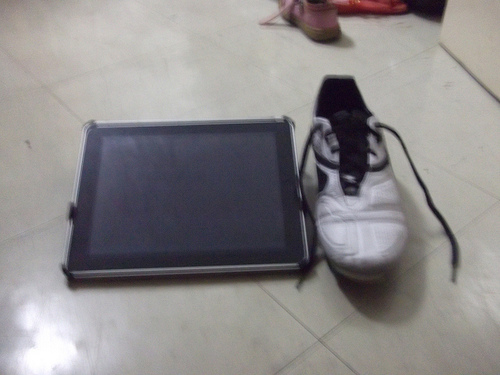<image>
Is the ipad next to the shoe? Yes. The ipad is positioned adjacent to the shoe, located nearby in the same general area. Is the shoelace in the shoe? Yes. The shoelace is contained within or inside the shoe, showing a containment relationship. Is the shoe in front of the wall? Yes. The shoe is positioned in front of the wall, appearing closer to the camera viewpoint. 